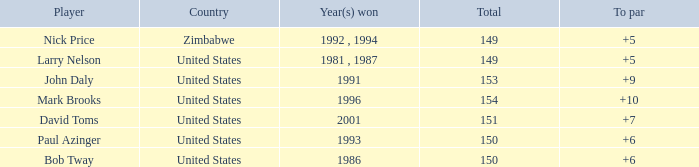What is Zimbabwe's total with a to par higher than 5? None. 